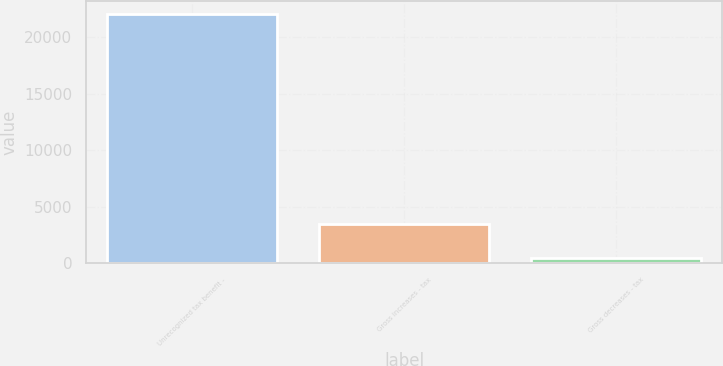Convert chart. <chart><loc_0><loc_0><loc_500><loc_500><bar_chart><fcel>Unrecognized tax benefit -<fcel>Gross increases - tax<fcel>Gross decreases - tax<nl><fcel>22104<fcel>3507<fcel>495<nl></chart> 